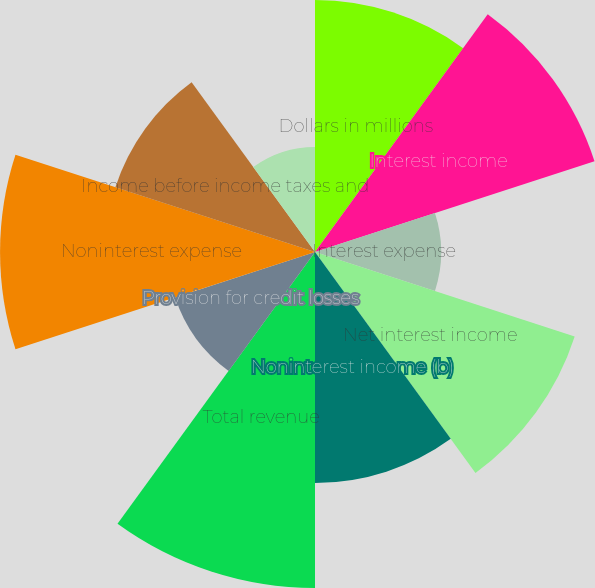Convert chart to OTSL. <chart><loc_0><loc_0><loc_500><loc_500><pie_chart><fcel>Dollars in millions<fcel>Interest income<fcel>Interest expense<fcel>Net interest income<fcel>Noninterest income (b)<fcel>Total revenue<fcel>Provision for credit losses<fcel>Noninterest expense<fcel>Income before income taxes and<fcel>Income taxes<nl><fcel>11.01%<fcel>12.84%<fcel>5.51%<fcel>11.93%<fcel>10.09%<fcel>14.68%<fcel>6.42%<fcel>13.76%<fcel>9.17%<fcel>4.59%<nl></chart> 